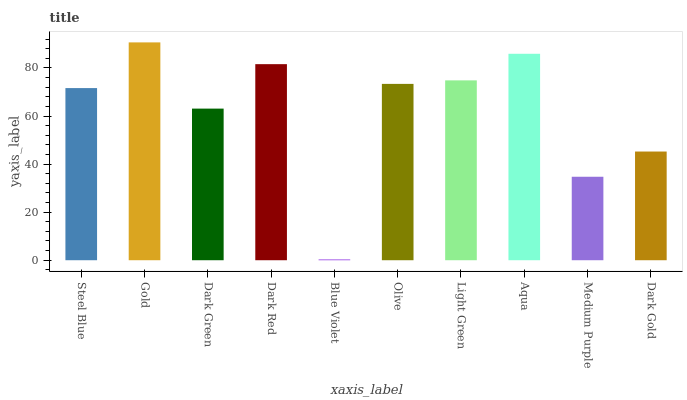Is Blue Violet the minimum?
Answer yes or no. Yes. Is Gold the maximum?
Answer yes or no. Yes. Is Dark Green the minimum?
Answer yes or no. No. Is Dark Green the maximum?
Answer yes or no. No. Is Gold greater than Dark Green?
Answer yes or no. Yes. Is Dark Green less than Gold?
Answer yes or no. Yes. Is Dark Green greater than Gold?
Answer yes or no. No. Is Gold less than Dark Green?
Answer yes or no. No. Is Olive the high median?
Answer yes or no. Yes. Is Steel Blue the low median?
Answer yes or no. Yes. Is Dark Red the high median?
Answer yes or no. No. Is Olive the low median?
Answer yes or no. No. 